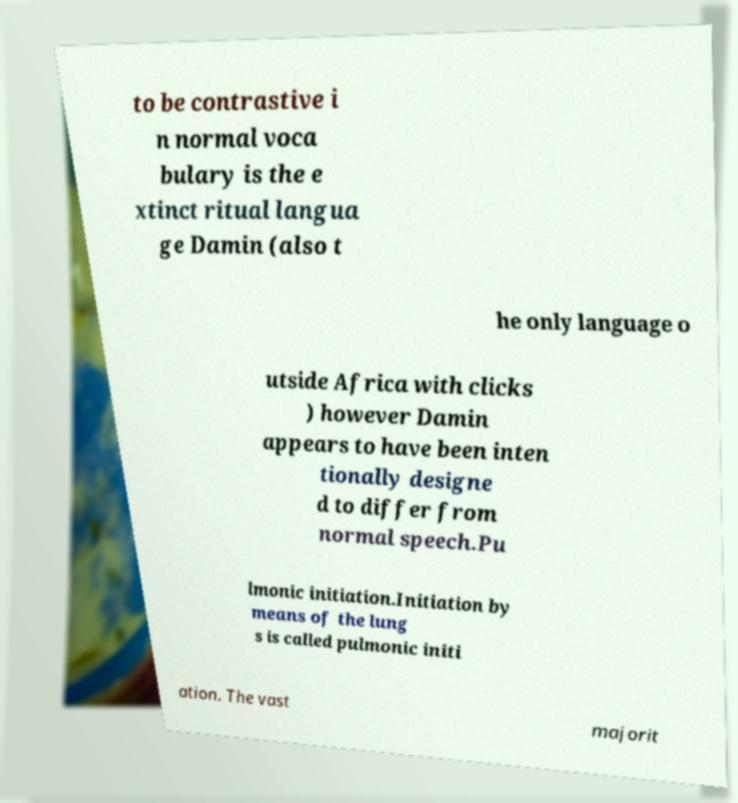Please identify and transcribe the text found in this image. to be contrastive i n normal voca bulary is the e xtinct ritual langua ge Damin (also t he only language o utside Africa with clicks ) however Damin appears to have been inten tionally designe d to differ from normal speech.Pu lmonic initiation.Initiation by means of the lung s is called pulmonic initi ation. The vast majorit 